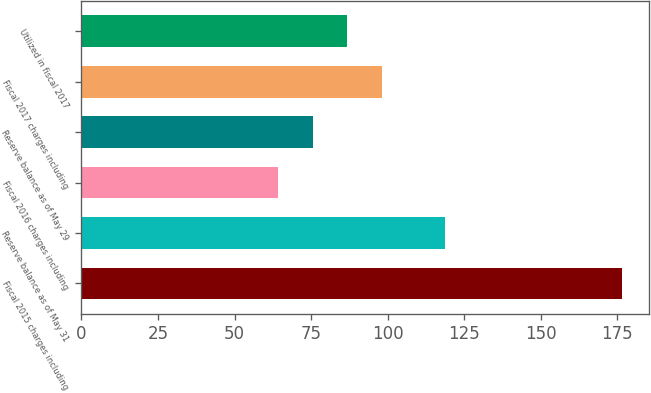<chart> <loc_0><loc_0><loc_500><loc_500><bar_chart><fcel>Fiscal 2015 charges including<fcel>Reserve balance as of May 31<fcel>Fiscal 2016 charges including<fcel>Reserve balance as of May 29<fcel>Fiscal 2017 charges including<fcel>Utilized in fiscal 2017<nl><fcel>176.4<fcel>118.6<fcel>64.3<fcel>75.51<fcel>98.01<fcel>86.8<nl></chart> 